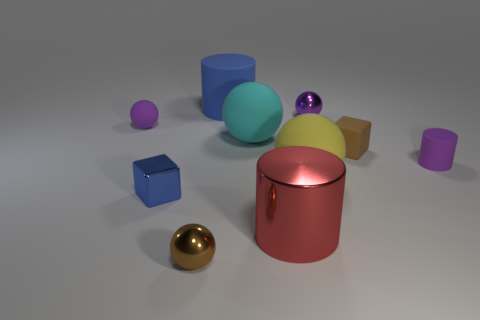What is the relationship between the sizes of the objects? The objects vary greatly in size, ranging from the tiny purple sphere to the much larger turquoise ball. The golden sphere, although not as large as the turquoise one, is substantially larger than the purple one. The cuboid objects also differ in size, and the cylindrical objects present a range of heights and diameters, suggesting a deliberate assortment to display diversity in dimensions. 